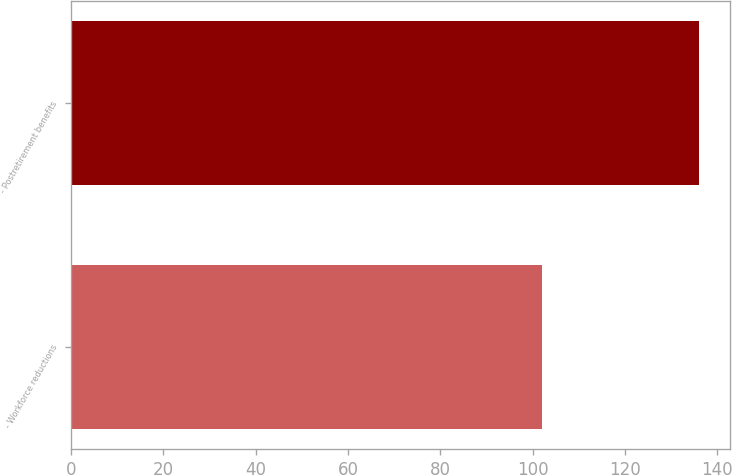<chart> <loc_0><loc_0><loc_500><loc_500><bar_chart><fcel>- Workforce reductions<fcel>- Postretirement benefits<nl><fcel>102<fcel>136<nl></chart> 